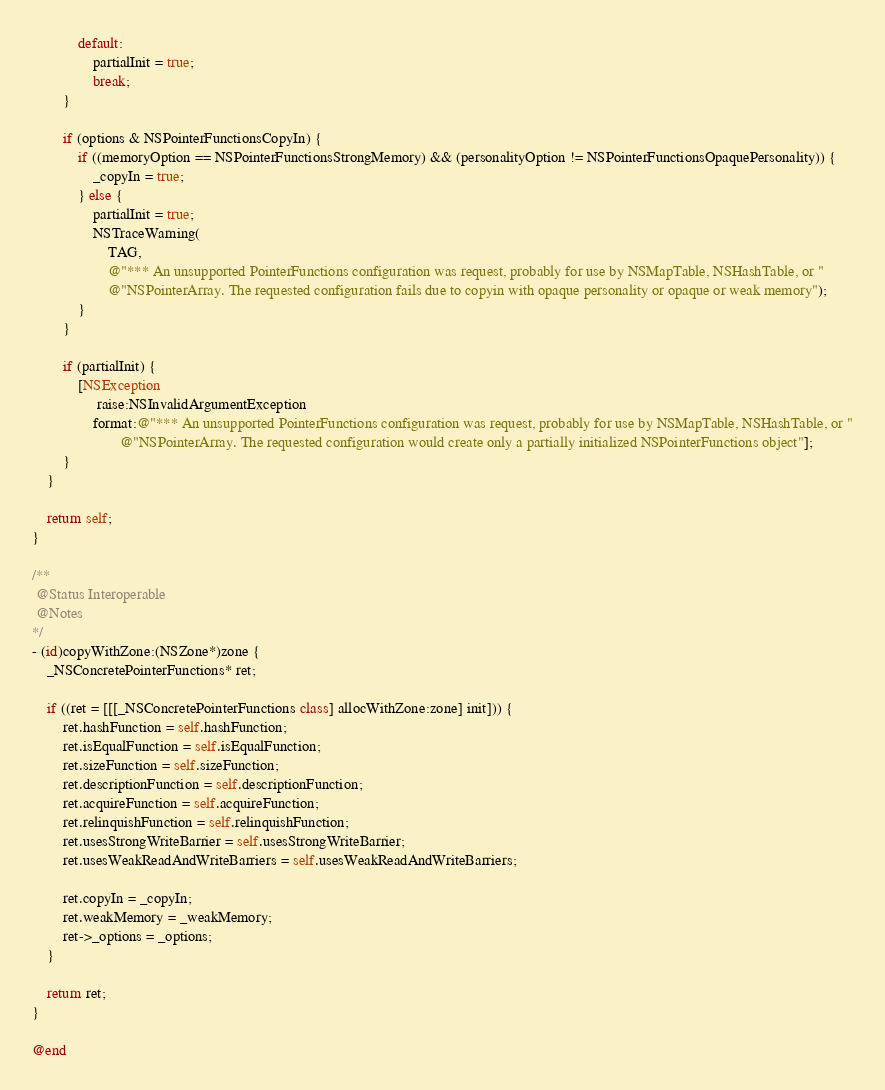Convert code to text. <code><loc_0><loc_0><loc_500><loc_500><_ObjectiveC_>            default:
                partialInit = true;
                break;
        }

        if (options & NSPointerFunctionsCopyIn) {
            if ((memoryOption == NSPointerFunctionsStrongMemory) && (personalityOption != NSPointerFunctionsOpaquePersonality)) {
                _copyIn = true;
            } else {
                partialInit = true;
                NSTraceWarning(
                    TAG,
                    @"*** An unsupported PointerFunctions configuration was request, probably for use by NSMapTable, NSHashTable, or "
                    @"NSPointerArray. The requested configuration fails due to copyin with opaque personality or opaque or weak memory");
            }
        }

        if (partialInit) {
            [NSException
                 raise:NSInvalidArgumentException
                format:@"*** An unsupported PointerFunctions configuration was request, probably for use by NSMapTable, NSHashTable, or "
                       @"NSPointerArray. The requested configuration would create only a partially initialized NSPointerFunctions object"];
        }
    }

    return self;
}

/**
 @Status Interoperable
 @Notes
*/
- (id)copyWithZone:(NSZone*)zone {
    _NSConcretePointerFunctions* ret;

    if ((ret = [[[_NSConcretePointerFunctions class] allocWithZone:zone] init])) {
        ret.hashFunction = self.hashFunction;
        ret.isEqualFunction = self.isEqualFunction;
        ret.sizeFunction = self.sizeFunction;
        ret.descriptionFunction = self.descriptionFunction;
        ret.acquireFunction = self.acquireFunction;
        ret.relinquishFunction = self.relinquishFunction;
        ret.usesStrongWriteBarrier = self.usesStrongWriteBarrier;
        ret.usesWeakReadAndWriteBarriers = self.usesWeakReadAndWriteBarriers;

        ret.copyIn = _copyIn;
        ret.weakMemory = _weakMemory;
        ret->_options = _options;
    }

    return ret;
}

@end
</code> 